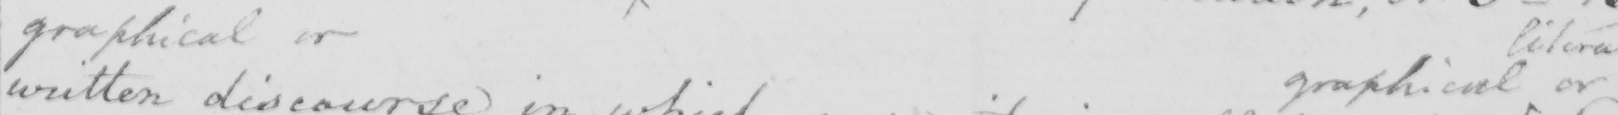Can you read and transcribe this handwriting? graphical or graphical or 